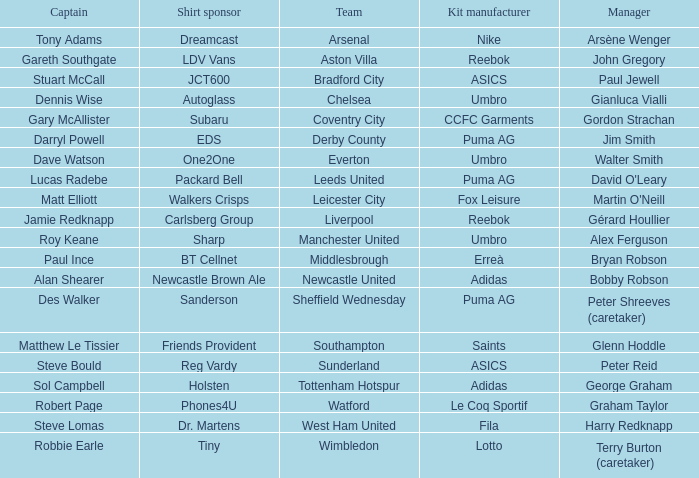Which team is under the direction of david o'leary? Leeds United. 